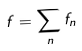<formula> <loc_0><loc_0><loc_500><loc_500>f = \sum _ { n } f _ { n }</formula> 